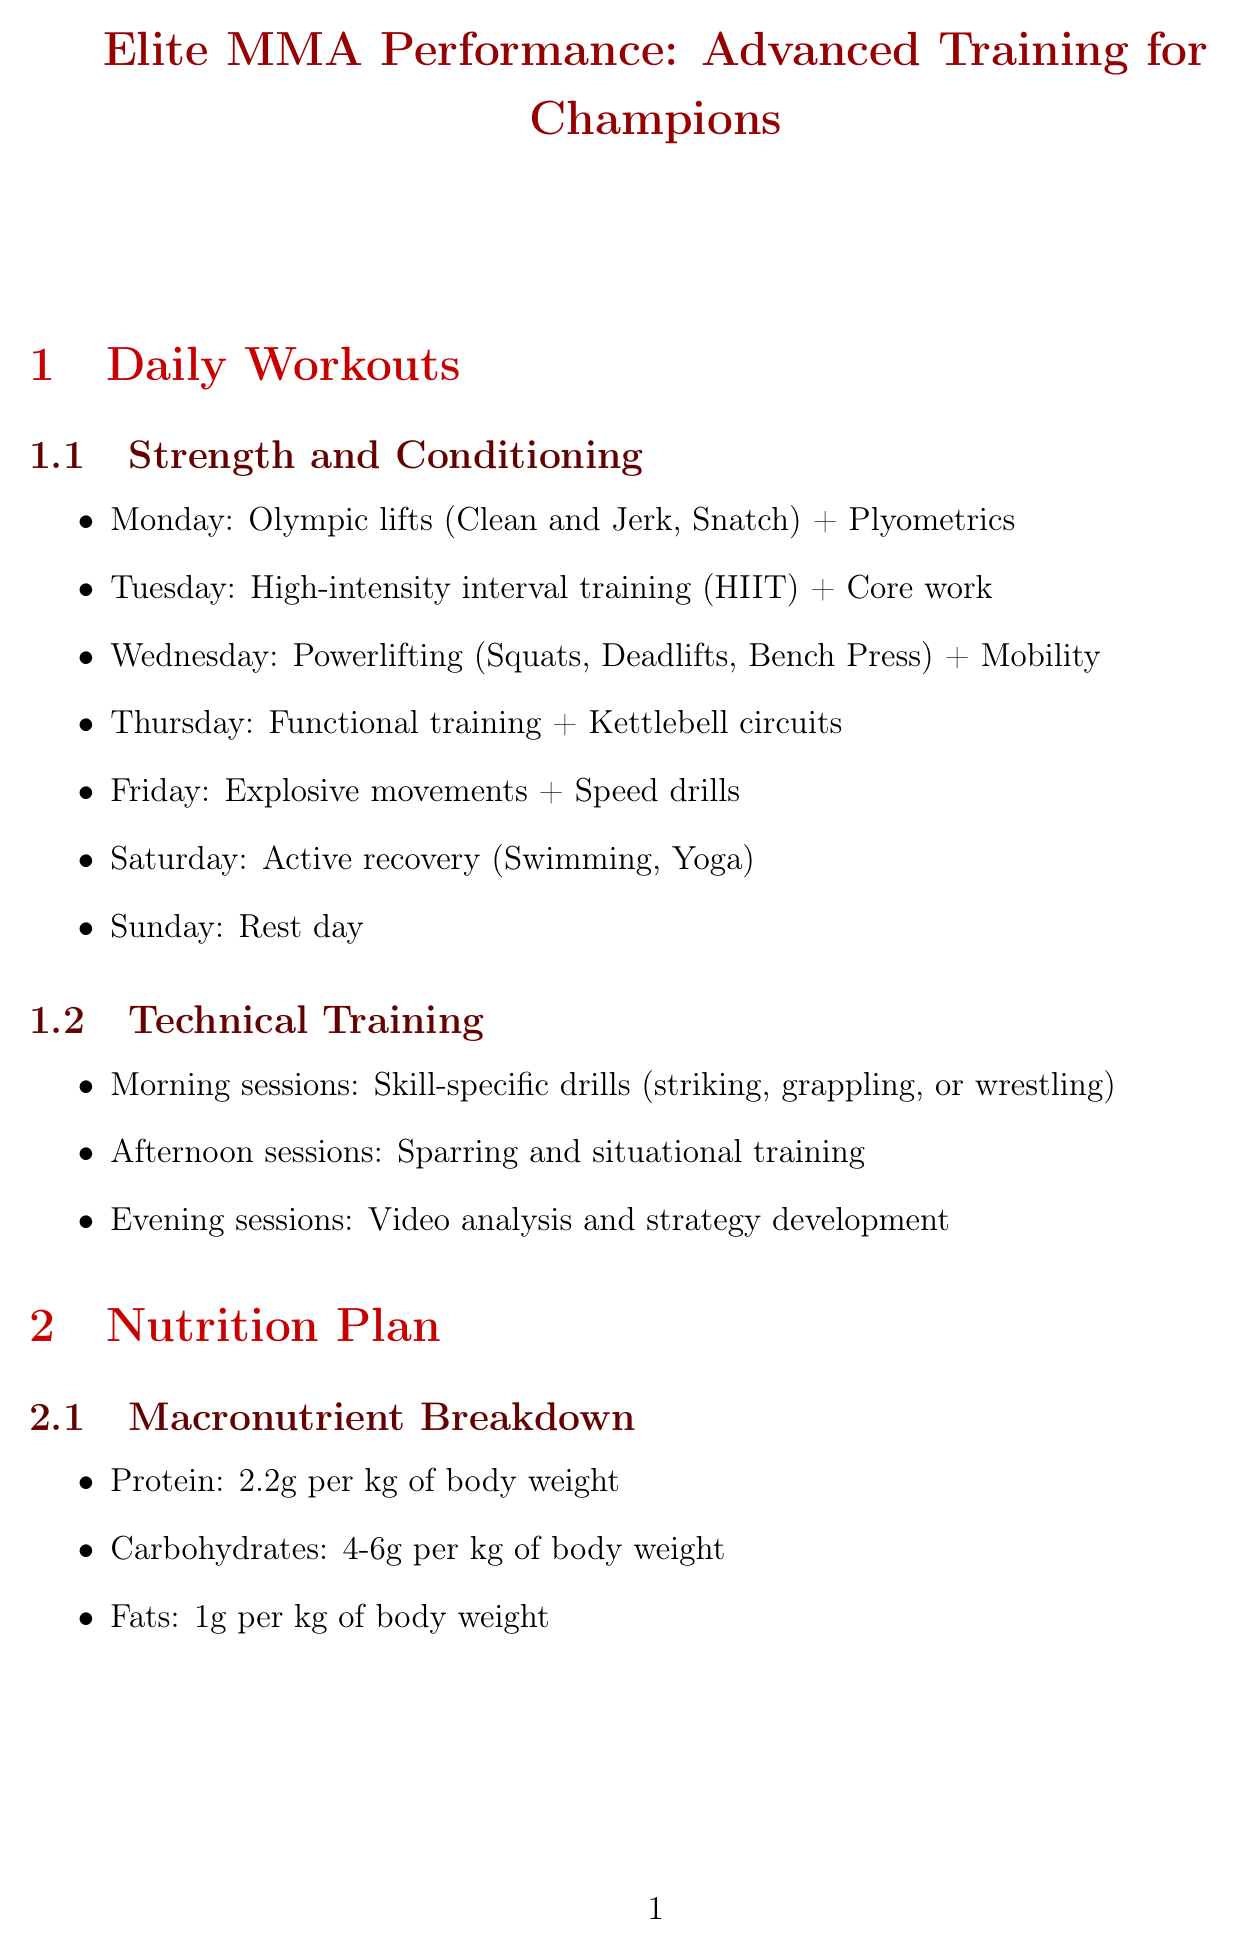What is the title of the manual? The title of the manual is stated at the beginning of the document.
Answer: Elite MMA Performance: Advanced Training for Champions How many times per week should one perform cryotherapy? The document specifies the frequency of cryotherapy sessions within the recovery techniques section.
Answer: 2-3 times per week What is the protein intake recommendation per kg of body weight? The manual provides specific macronutrient breakdowns, including protein intake recommendations.
Answer: 2.2g What are the components of the Saturday workout? The document lists activities for each workout day, including Saturday's focus on active recovery.
Answer: Active recovery (Swimming, Yoga) How often should strength assessments take place? The document outlines the frequency of various performance testing, including strength assessments.
Answer: Quarterly What is included in the mental recovery techniques? This question asks for an overview of mental recovery methods listed in the manual.
Answer: Mindfulness meditation, Visualization exercises, Cognitive behavioral therapy sessions, Float tank sessions What do athletes use during training as per the supplement section? The manual describes various supplements used during training.
Answer: BCAAs What is the focus of Wednesday's training? The daily workouts section provides specific focus areas for each day, including Wednesday.
Answer: Powerlifting (Squats, Deadlifts, Bench Press) + Mobility 